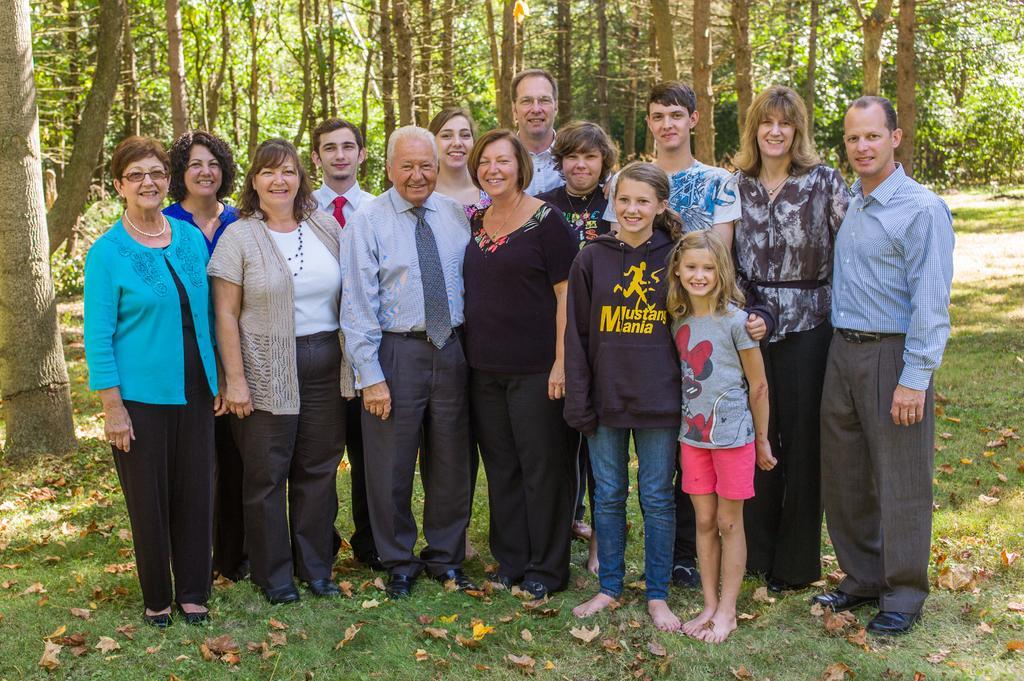Can you describe this image briefly? In the picture we can see a group of people are standing on the grass surface and they are smiling and behind them we can see the trees. 